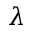<formula> <loc_0><loc_0><loc_500><loc_500>\lambda</formula> 